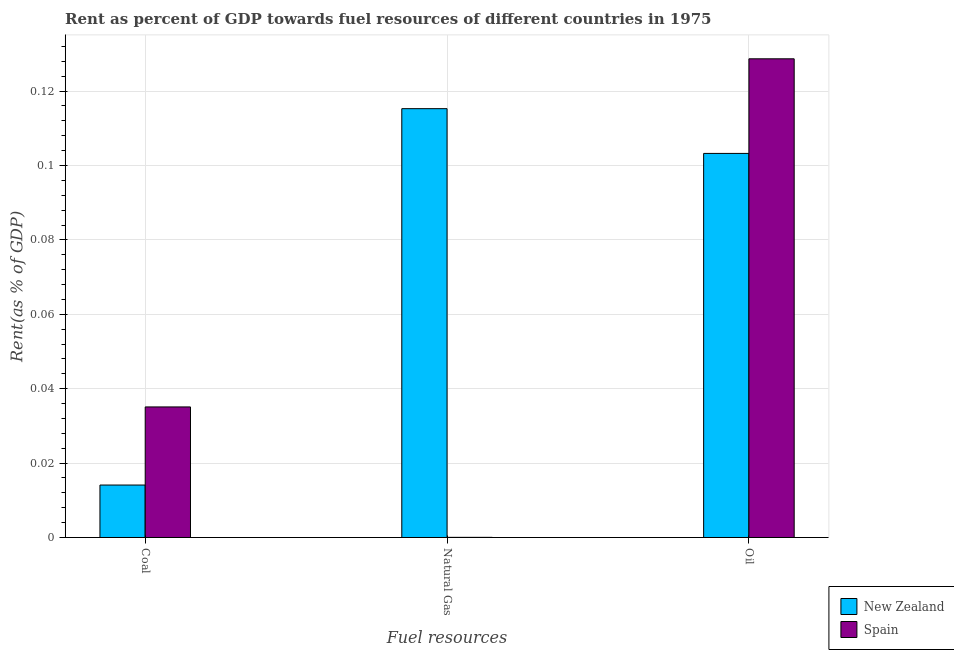How many groups of bars are there?
Provide a succinct answer. 3. Are the number of bars per tick equal to the number of legend labels?
Ensure brevity in your answer.  Yes. Are the number of bars on each tick of the X-axis equal?
Your answer should be very brief. Yes. What is the label of the 2nd group of bars from the left?
Offer a terse response. Natural Gas. What is the rent towards coal in Spain?
Ensure brevity in your answer.  0.04. Across all countries, what is the maximum rent towards natural gas?
Provide a succinct answer. 0.12. Across all countries, what is the minimum rent towards coal?
Provide a succinct answer. 0.01. In which country was the rent towards natural gas maximum?
Provide a short and direct response. New Zealand. In which country was the rent towards coal minimum?
Offer a terse response. New Zealand. What is the total rent towards natural gas in the graph?
Give a very brief answer. 0.12. What is the difference between the rent towards coal in New Zealand and that in Spain?
Your answer should be compact. -0.02. What is the difference between the rent towards coal in New Zealand and the rent towards natural gas in Spain?
Provide a succinct answer. 0.01. What is the average rent towards natural gas per country?
Your answer should be very brief. 0.06. What is the difference between the rent towards coal and rent towards oil in Spain?
Make the answer very short. -0.09. In how many countries, is the rent towards coal greater than 0.084 %?
Your response must be concise. 0. What is the ratio of the rent towards oil in New Zealand to that in Spain?
Provide a succinct answer. 0.8. What is the difference between the highest and the second highest rent towards natural gas?
Keep it short and to the point. 0.12. What is the difference between the highest and the lowest rent towards natural gas?
Keep it short and to the point. 0.12. In how many countries, is the rent towards oil greater than the average rent towards oil taken over all countries?
Make the answer very short. 1. Is the sum of the rent towards coal in New Zealand and Spain greater than the maximum rent towards natural gas across all countries?
Ensure brevity in your answer.  No. What does the 2nd bar from the left in Oil represents?
Your answer should be compact. Spain. What does the 2nd bar from the right in Oil represents?
Keep it short and to the point. New Zealand. How many countries are there in the graph?
Keep it short and to the point. 2. Are the values on the major ticks of Y-axis written in scientific E-notation?
Ensure brevity in your answer.  No. Does the graph contain any zero values?
Provide a succinct answer. No. Where does the legend appear in the graph?
Provide a short and direct response. Bottom right. How many legend labels are there?
Provide a short and direct response. 2. How are the legend labels stacked?
Offer a very short reply. Vertical. What is the title of the graph?
Make the answer very short. Rent as percent of GDP towards fuel resources of different countries in 1975. Does "Sweden" appear as one of the legend labels in the graph?
Ensure brevity in your answer.  No. What is the label or title of the X-axis?
Keep it short and to the point. Fuel resources. What is the label or title of the Y-axis?
Provide a succinct answer. Rent(as % of GDP). What is the Rent(as % of GDP) in New Zealand in Coal?
Provide a short and direct response. 0.01. What is the Rent(as % of GDP) in Spain in Coal?
Provide a short and direct response. 0.04. What is the Rent(as % of GDP) in New Zealand in Natural Gas?
Keep it short and to the point. 0.12. What is the Rent(as % of GDP) in Spain in Natural Gas?
Your response must be concise. 3.61574922893464e-5. What is the Rent(as % of GDP) in New Zealand in Oil?
Offer a very short reply. 0.1. What is the Rent(as % of GDP) in Spain in Oil?
Your answer should be compact. 0.13. Across all Fuel resources, what is the maximum Rent(as % of GDP) in New Zealand?
Your answer should be very brief. 0.12. Across all Fuel resources, what is the maximum Rent(as % of GDP) of Spain?
Offer a terse response. 0.13. Across all Fuel resources, what is the minimum Rent(as % of GDP) in New Zealand?
Ensure brevity in your answer.  0.01. Across all Fuel resources, what is the minimum Rent(as % of GDP) in Spain?
Your answer should be compact. 3.61574922893464e-5. What is the total Rent(as % of GDP) in New Zealand in the graph?
Your answer should be very brief. 0.23. What is the total Rent(as % of GDP) in Spain in the graph?
Your response must be concise. 0.16. What is the difference between the Rent(as % of GDP) of New Zealand in Coal and that in Natural Gas?
Offer a very short reply. -0.1. What is the difference between the Rent(as % of GDP) of Spain in Coal and that in Natural Gas?
Make the answer very short. 0.04. What is the difference between the Rent(as % of GDP) in New Zealand in Coal and that in Oil?
Ensure brevity in your answer.  -0.09. What is the difference between the Rent(as % of GDP) of Spain in Coal and that in Oil?
Keep it short and to the point. -0.09. What is the difference between the Rent(as % of GDP) in New Zealand in Natural Gas and that in Oil?
Your answer should be compact. 0.01. What is the difference between the Rent(as % of GDP) of Spain in Natural Gas and that in Oil?
Give a very brief answer. -0.13. What is the difference between the Rent(as % of GDP) of New Zealand in Coal and the Rent(as % of GDP) of Spain in Natural Gas?
Provide a succinct answer. 0.01. What is the difference between the Rent(as % of GDP) in New Zealand in Coal and the Rent(as % of GDP) in Spain in Oil?
Provide a succinct answer. -0.11. What is the difference between the Rent(as % of GDP) of New Zealand in Natural Gas and the Rent(as % of GDP) of Spain in Oil?
Offer a very short reply. -0.01. What is the average Rent(as % of GDP) in New Zealand per Fuel resources?
Provide a succinct answer. 0.08. What is the average Rent(as % of GDP) in Spain per Fuel resources?
Your answer should be compact. 0.05. What is the difference between the Rent(as % of GDP) in New Zealand and Rent(as % of GDP) in Spain in Coal?
Provide a short and direct response. -0.02. What is the difference between the Rent(as % of GDP) of New Zealand and Rent(as % of GDP) of Spain in Natural Gas?
Your response must be concise. 0.12. What is the difference between the Rent(as % of GDP) in New Zealand and Rent(as % of GDP) in Spain in Oil?
Your answer should be very brief. -0.03. What is the ratio of the Rent(as % of GDP) in New Zealand in Coal to that in Natural Gas?
Provide a short and direct response. 0.12. What is the ratio of the Rent(as % of GDP) in Spain in Coal to that in Natural Gas?
Keep it short and to the point. 970.61. What is the ratio of the Rent(as % of GDP) of New Zealand in Coal to that in Oil?
Keep it short and to the point. 0.14. What is the ratio of the Rent(as % of GDP) in Spain in Coal to that in Oil?
Your answer should be compact. 0.27. What is the ratio of the Rent(as % of GDP) of New Zealand in Natural Gas to that in Oil?
Make the answer very short. 1.12. What is the difference between the highest and the second highest Rent(as % of GDP) of New Zealand?
Ensure brevity in your answer.  0.01. What is the difference between the highest and the second highest Rent(as % of GDP) of Spain?
Keep it short and to the point. 0.09. What is the difference between the highest and the lowest Rent(as % of GDP) in New Zealand?
Give a very brief answer. 0.1. What is the difference between the highest and the lowest Rent(as % of GDP) of Spain?
Provide a succinct answer. 0.13. 